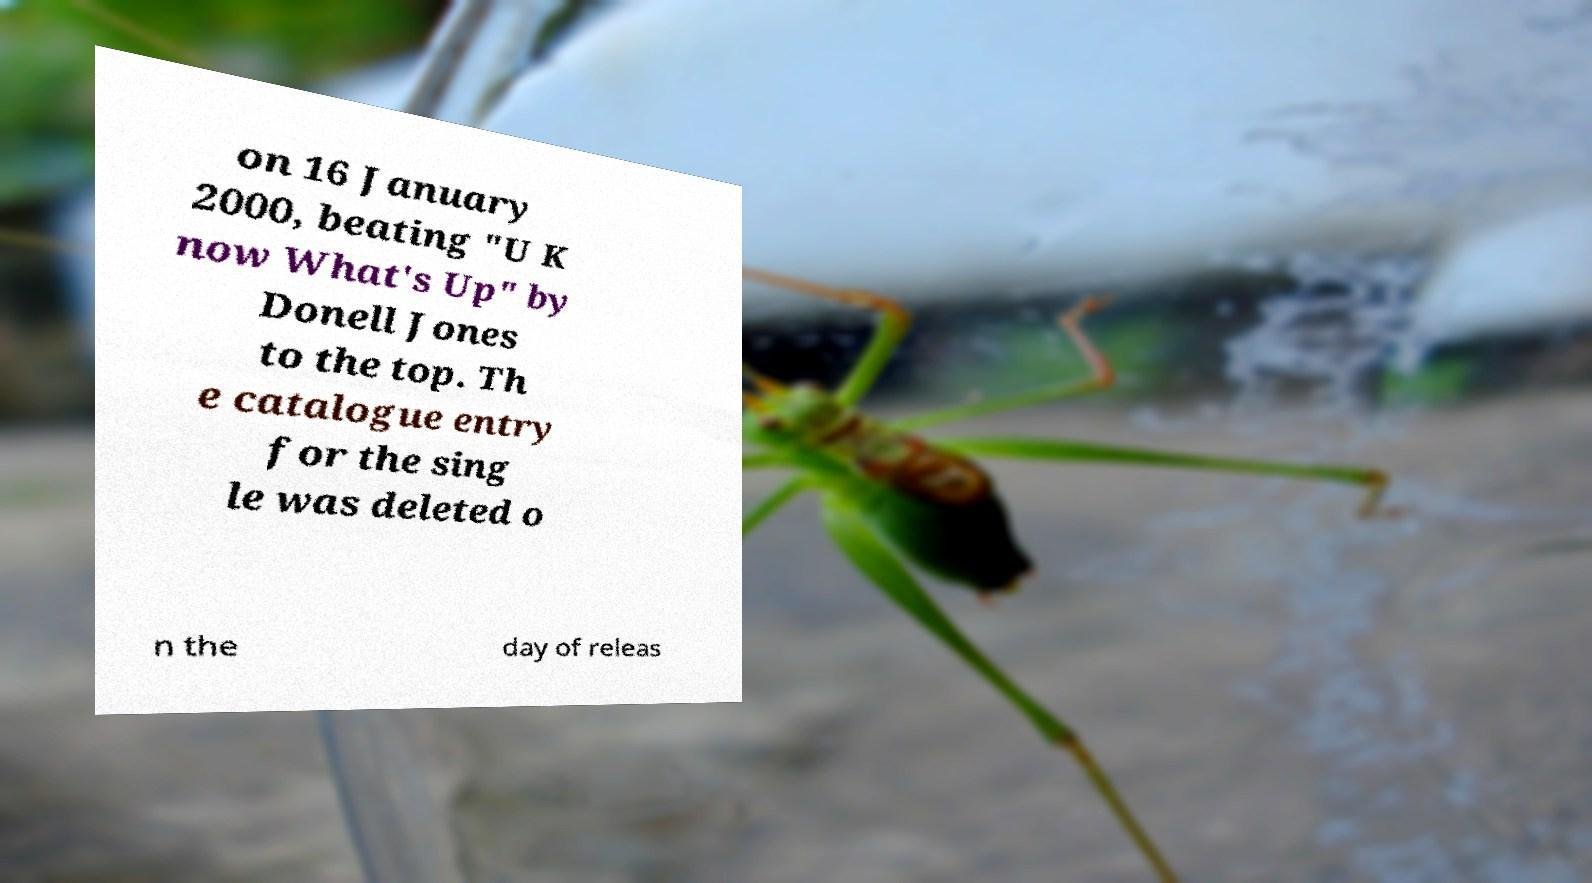Could you assist in decoding the text presented in this image and type it out clearly? on 16 January 2000, beating "U K now What's Up" by Donell Jones to the top. Th e catalogue entry for the sing le was deleted o n the day of releas 